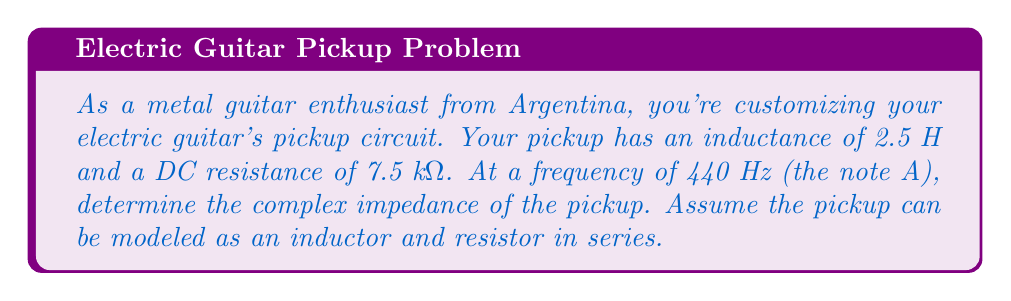What is the answer to this math problem? To solve this problem, we'll follow these steps:

1) The impedance of an inductor is given by $Z_L = j\omega L$, where:
   - $j$ is the imaginary unit
   - $\omega = 2\pi f$ is the angular frequency
   - $L$ is the inductance

2) The impedance of a resistor is simply $Z_R = R$

3) For a series circuit, we add the impedances: $Z_{total} = Z_R + Z_L$

Let's calculate:

1) First, we need to find $\omega$:
   $\omega = 2\pi f = 2\pi(440) \approx 2763.89$ rad/s

2) Now, let's calculate the inductive reactance:
   $Z_L = j\omega L = j(2763.89)(2.5) = j6909.73$ Ω

3) The resistive component is simply 7500 Ω

4) Adding these together:
   $Z_{total} = 7500 + j6909.73$ Ω

This is our complex impedance in rectangular form. We can also express it in polar form:

$|Z| = \sqrt{7500^2 + 6909.73^2} \approx 10194.04$ Ω
$\theta = \tan^{-1}(\frac{6909.73}{7500}) \approx 42.64°$

So in polar form: $Z_{total} \approx 10194.04 \angle 42.64°$ Ω
Answer: $Z_{total} = 7500 + j6909.73$ Ω (rectangular form)
or
$Z_{total} \approx 10194.04 \angle 42.64°$ Ω (polar form) 